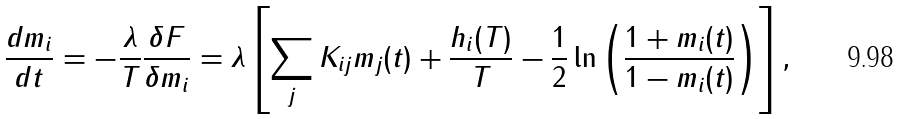<formula> <loc_0><loc_0><loc_500><loc_500>\frac { d m _ { i } } { d t } = - \frac { \lambda } { T } \frac { \delta F } { \delta m _ { i } } = \lambda \left [ \sum _ { j } K _ { i j } m _ { j } ( t ) + \frac { h _ { i } ( T ) } { T } - \frac { 1 } { 2 } \ln \left ( \frac { 1 + m _ { i } ( t ) } { 1 - m _ { i } ( t ) } \right ) \right ] ,</formula> 